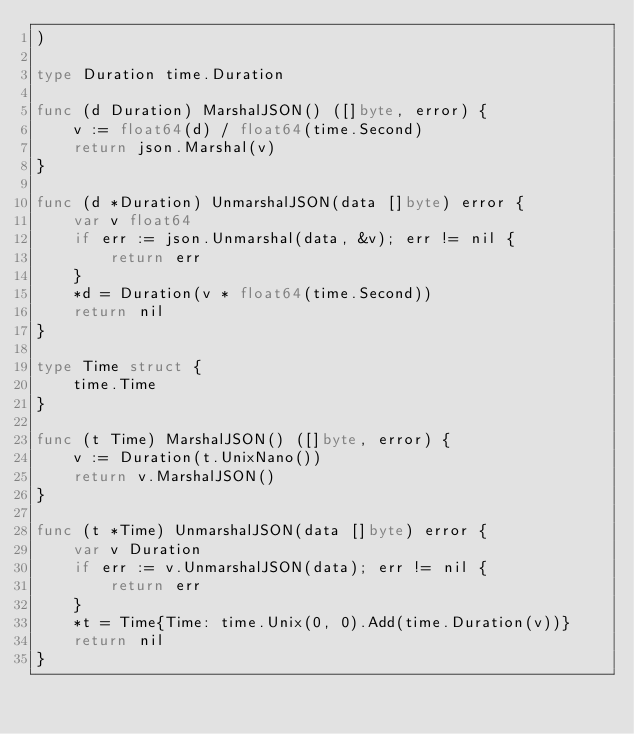Convert code to text. <code><loc_0><loc_0><loc_500><loc_500><_Go_>)

type Duration time.Duration

func (d Duration) MarshalJSON() ([]byte, error) {
	v := float64(d) / float64(time.Second)
	return json.Marshal(v)
}

func (d *Duration) UnmarshalJSON(data []byte) error {
	var v float64
	if err := json.Unmarshal(data, &v); err != nil {
		return err
	}
	*d = Duration(v * float64(time.Second))
	return nil
}

type Time struct {
	time.Time
}

func (t Time) MarshalJSON() ([]byte, error) {
	v := Duration(t.UnixNano())
	return v.MarshalJSON()
}

func (t *Time) UnmarshalJSON(data []byte) error {
	var v Duration
	if err := v.UnmarshalJSON(data); err != nil {
		return err
	}
	*t = Time{Time: time.Unix(0, 0).Add(time.Duration(v))}
	return nil
}
</code> 